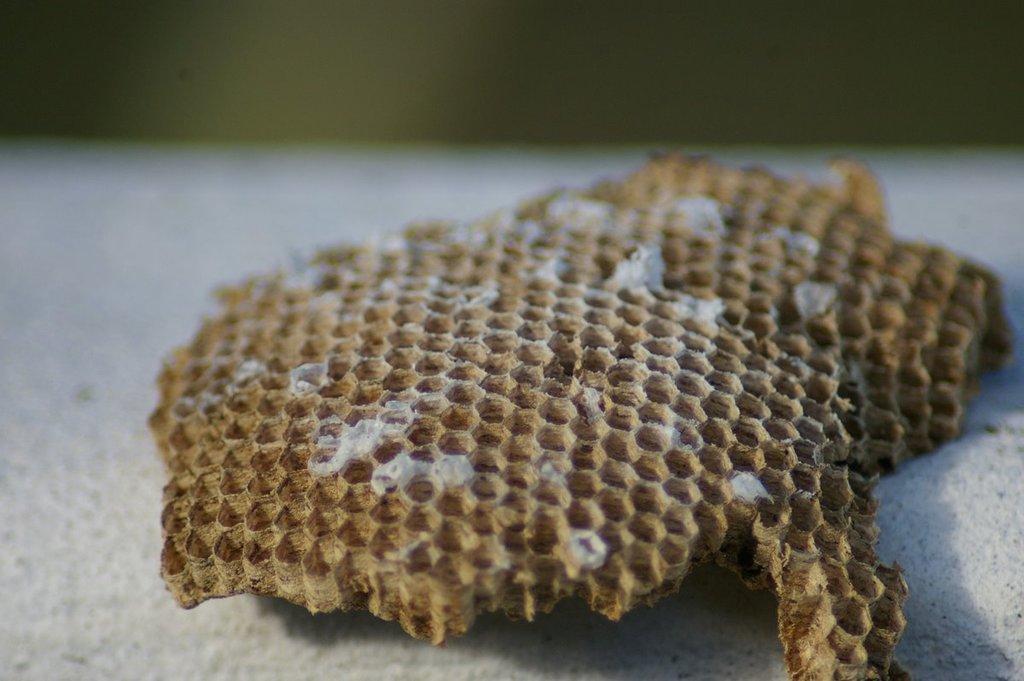In one or two sentences, can you explain what this image depicts? In this image there is a dried honey bee wax in the sand. 